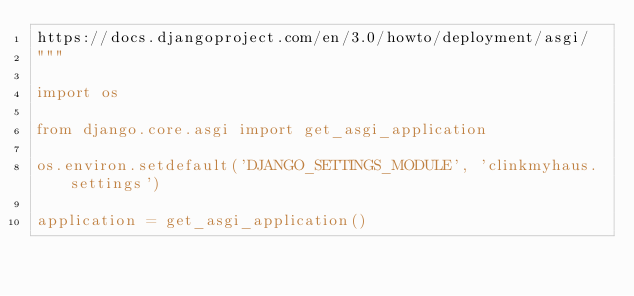Convert code to text. <code><loc_0><loc_0><loc_500><loc_500><_Python_>https://docs.djangoproject.com/en/3.0/howto/deployment/asgi/
"""

import os

from django.core.asgi import get_asgi_application

os.environ.setdefault('DJANGO_SETTINGS_MODULE', 'clinkmyhaus.settings')

application = get_asgi_application()
</code> 